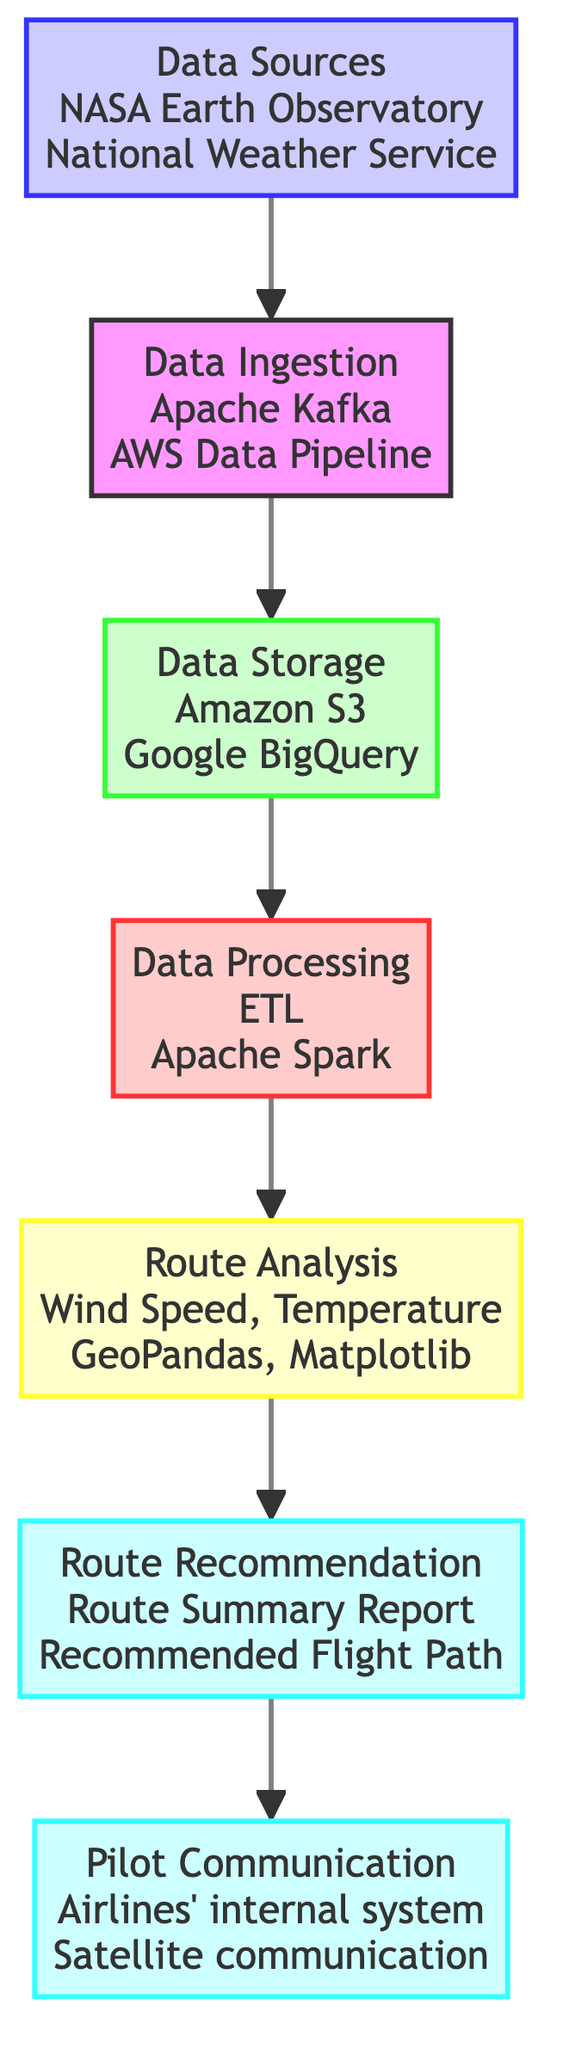What are the data sources mentioned in the diagram? The diagram lists several data sources, specifically NASA Earth Observatory, Google Maps API, and US Geological Survey for geographical data, and National Weather Service, European Centre for Medium-Range Weather Forecasts, and Windy API for meteorological data.
Answer: NASA Earth Observatory, Google Maps API, US Geological Survey, National Weather Service, European Centre for Medium-Range Weather Forecasts, Windy API How many storage systems are identified in the diagram? The diagram specifies three storage systems, which are Amazon S3, Google BigQuery, and Azure Blob Storage. By counting these systems listed under the Data Storage section, we conclude the total.
Answer: 3 What is the primary purpose of the Data Processing step? The Data Processing step's primary purpose is to clean, transform, and enrich data for practical use, which is mentioned explicitly in the description associated with that node.
Answer: Cleaning, transforming, and enriching data Which tools are used for Route Analysis according to the diagram? The Route Analysis step utilizes GeoPandas and Matplotlib for analyzing the geographical and meteorological data in order to recommend optimal flight routes. These are the tools explicitly listed under the Route Analysis node.
Answer: GeoPandas, Matplotlib What is the output of the Route Recommendation step? The Route Recommendation step outputs a Route Summary Report, Recommended Flight Path, and Weather Impact Overview. These outputs are clearly listed in the description associated with that node.
Answer: Route Summary Report, Recommended Flight Path, Weather Impact Overview What is the flow direction of the diagram? The flow direction of the diagram is from bottom to up, as indicated in the given instructions and reflected in the sequential arrangement of nodes moving upward from Data Sources to Pilot Communication.
Answer: Bottom to up What connects Data Storage to Data Processing? Data Storage is directly connected to Data Processing in the flow chart, indicating a sequential step where stored data is processed next. This connection signifies that the output from Data Storage becomes the input for Data Processing.
Answer: Data Ingestion How many tools are listed for Data Ingestion? The diagram identifies three tools for Data Ingestion: Apache Kafka, AWS Data Pipeline, and Google Cloud Dataflow. By counting the tools listed, we find the total.
Answer: 3 What are the communication channels used for Pilot Communication? The communication channels for the Pilot Communication step include the Airlines' internal communication system, Satellite communication, and Pilot Briefing, which are clearly mentioned under that node.
Answer: Airlines' internal communication system, Satellite communication, Pilot Briefing 